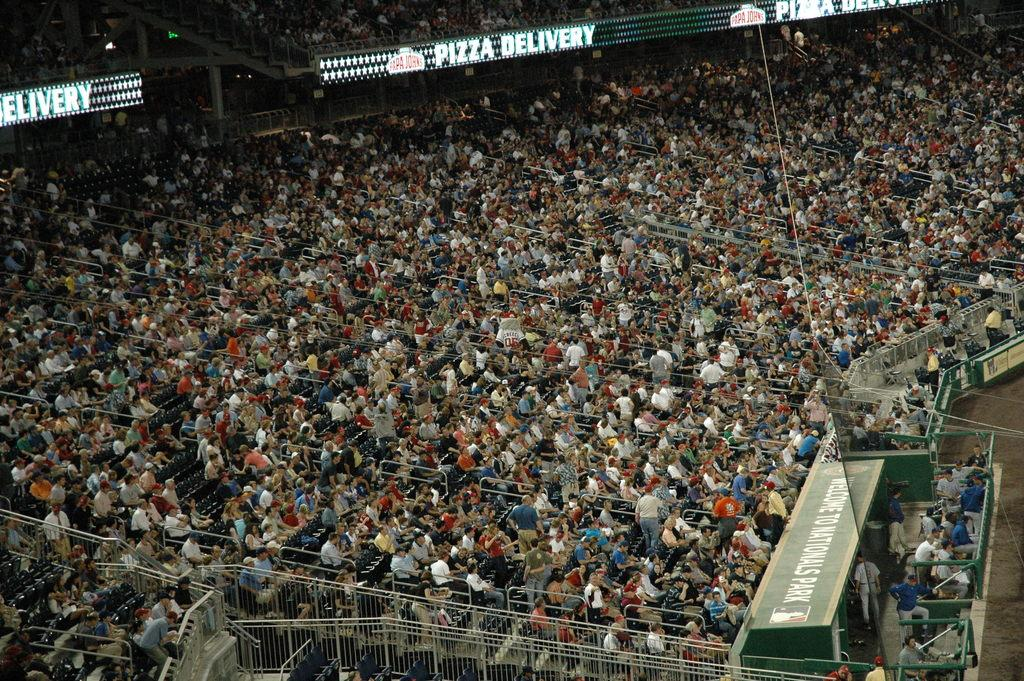What type of location is depicted in the image? The image appears to depict a stadium. What can be seen in the stadium? There is a crowd of people in the image. How are the people in the image positioned? The people are sitting and facing towards the right side. What is visible on the right side of the image? There is a ground and boards present on the right side of the image. How many brothers are sitting together in the image? There is no information about brothers in the image, as it only shows a crowd of people in a stadium. 